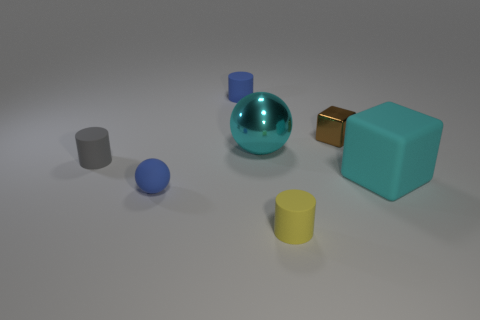Add 2 red objects. How many objects exist? 9 Subtract all spheres. How many objects are left? 5 Add 5 tiny purple rubber balls. How many tiny purple rubber balls exist? 5 Subtract 0 green spheres. How many objects are left? 7 Subtract all cyan balls. Subtract all small gray rubber things. How many objects are left? 5 Add 3 large cyan rubber things. How many large cyan rubber things are left? 4 